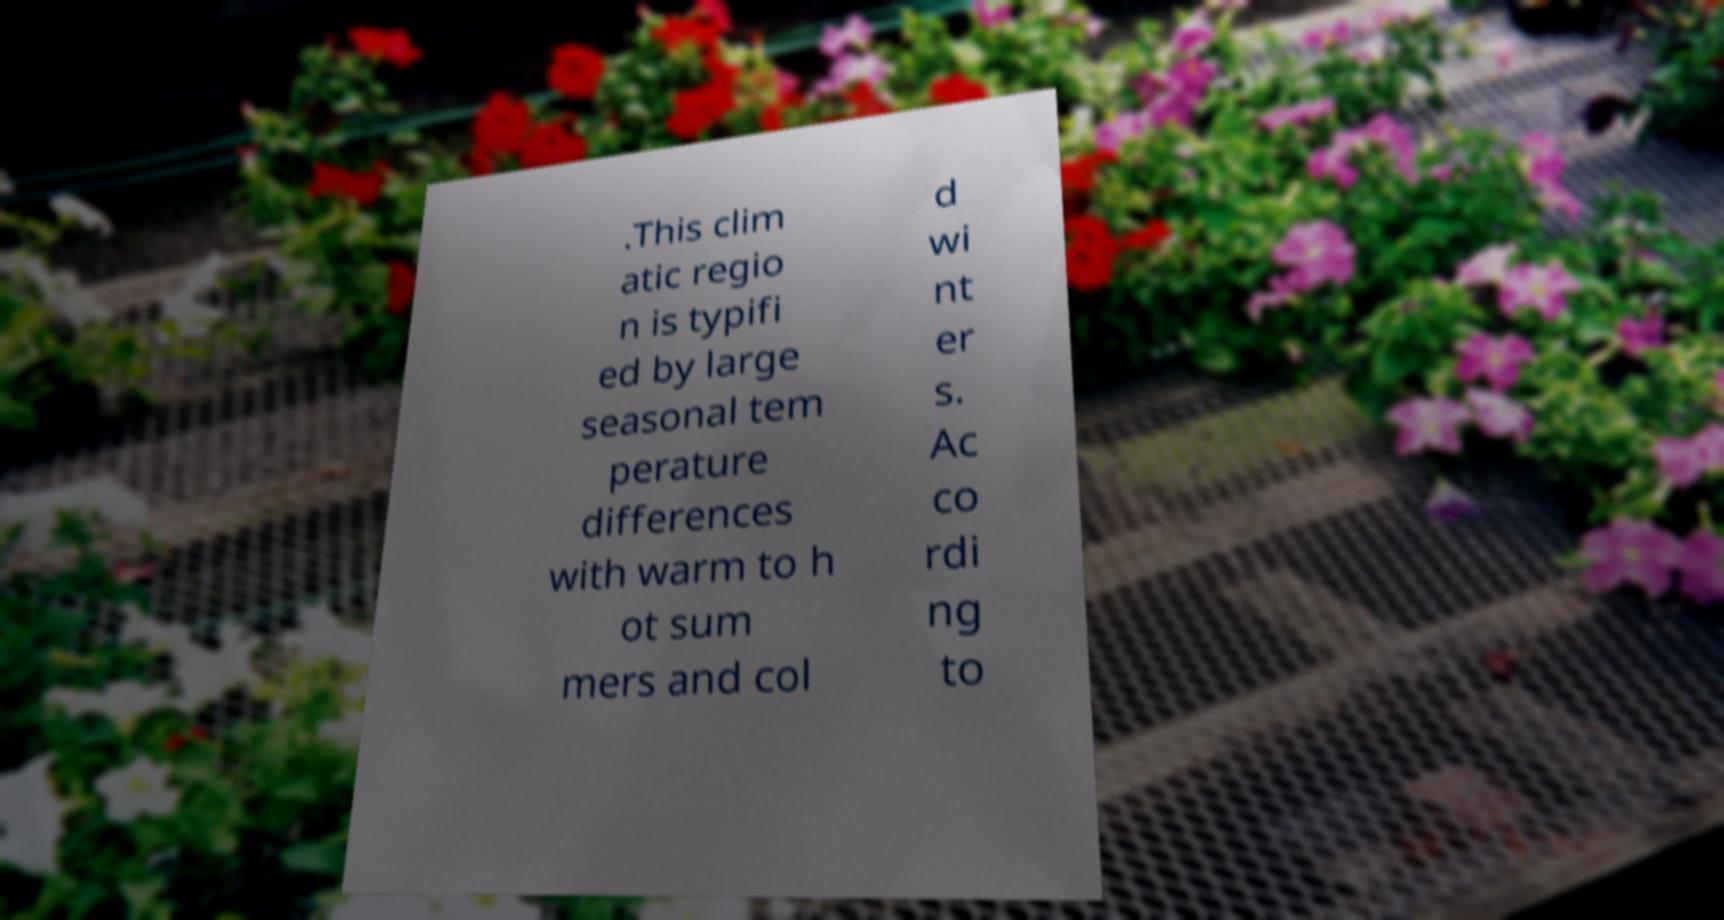Can you read and provide the text displayed in the image?This photo seems to have some interesting text. Can you extract and type it out for me? .This clim atic regio n is typifi ed by large seasonal tem perature differences with warm to h ot sum mers and col d wi nt er s. Ac co rdi ng to 